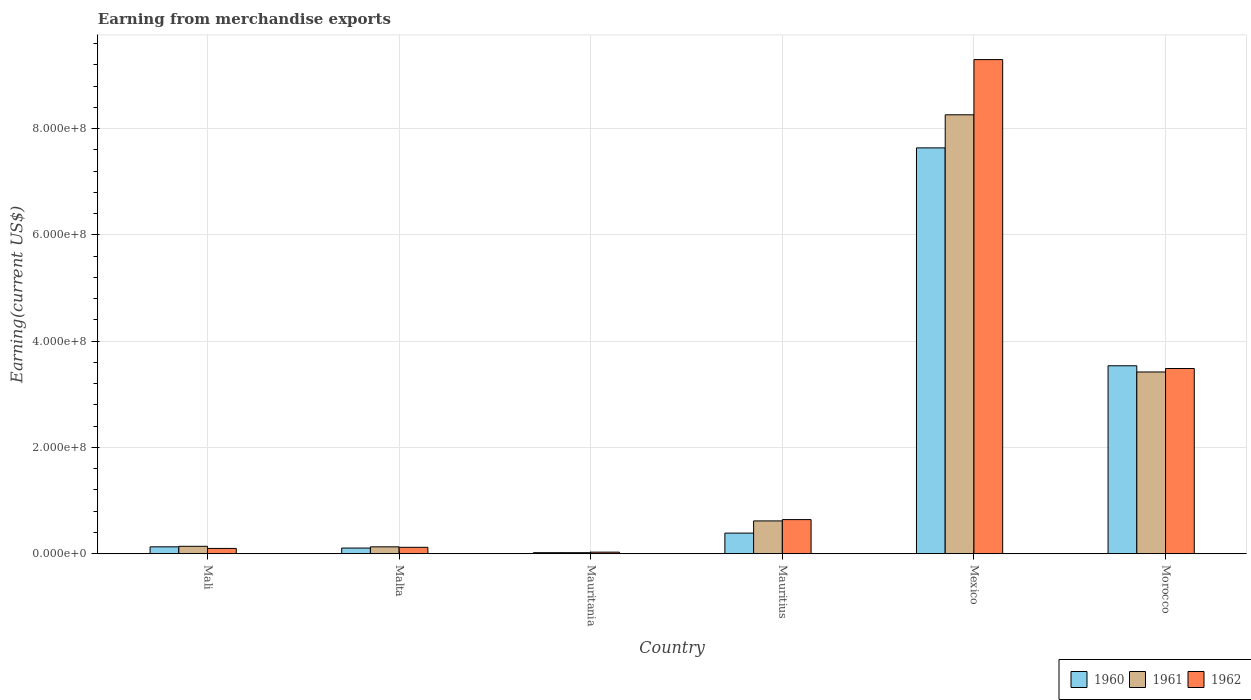How many groups of bars are there?
Make the answer very short. 6. How many bars are there on the 3rd tick from the left?
Your answer should be compact. 3. What is the amount earned from merchandise exports in 1960 in Mexico?
Provide a short and direct response. 7.64e+08. Across all countries, what is the maximum amount earned from merchandise exports in 1960?
Keep it short and to the point. 7.64e+08. Across all countries, what is the minimum amount earned from merchandise exports in 1961?
Ensure brevity in your answer.  2.00e+06. In which country was the amount earned from merchandise exports in 1961 minimum?
Provide a succinct answer. Mauritania. What is the total amount earned from merchandise exports in 1962 in the graph?
Provide a succinct answer. 1.37e+09. What is the difference between the amount earned from merchandise exports in 1960 in Mali and that in Mauritius?
Provide a succinct answer. -2.58e+07. What is the difference between the amount earned from merchandise exports in 1962 in Mauritania and the amount earned from merchandise exports in 1961 in Malta?
Provide a short and direct response. -1.00e+07. What is the average amount earned from merchandise exports in 1961 per country?
Make the answer very short. 2.10e+08. What is the difference between the amount earned from merchandise exports of/in 1960 and amount earned from merchandise exports of/in 1961 in Malta?
Keep it short and to the point. -2.30e+06. Is the amount earned from merchandise exports in 1961 in Mauritius less than that in Mexico?
Your response must be concise. Yes. What is the difference between the highest and the second highest amount earned from merchandise exports in 1960?
Your answer should be very brief. 4.10e+08. What is the difference between the highest and the lowest amount earned from merchandise exports in 1961?
Provide a short and direct response. 8.24e+08. In how many countries, is the amount earned from merchandise exports in 1960 greater than the average amount earned from merchandise exports in 1960 taken over all countries?
Keep it short and to the point. 2. Is the sum of the amount earned from merchandise exports in 1961 in Malta and Mauritania greater than the maximum amount earned from merchandise exports in 1960 across all countries?
Provide a succinct answer. No. Are all the bars in the graph horizontal?
Provide a short and direct response. No. What is the difference between two consecutive major ticks on the Y-axis?
Your answer should be very brief. 2.00e+08. Are the values on the major ticks of Y-axis written in scientific E-notation?
Your response must be concise. Yes. Does the graph contain any zero values?
Your answer should be compact. No. Does the graph contain grids?
Provide a short and direct response. Yes. Where does the legend appear in the graph?
Offer a terse response. Bottom right. How many legend labels are there?
Offer a very short reply. 3. What is the title of the graph?
Keep it short and to the point. Earning from merchandise exports. What is the label or title of the Y-axis?
Your answer should be very brief. Earning(current US$). What is the Earning(current US$) of 1960 in Mali?
Provide a succinct answer. 1.30e+07. What is the Earning(current US$) of 1961 in Mali?
Your response must be concise. 1.40e+07. What is the Earning(current US$) of 1960 in Malta?
Keep it short and to the point. 1.07e+07. What is the Earning(current US$) of 1961 in Malta?
Keep it short and to the point. 1.30e+07. What is the Earning(current US$) in 1962 in Malta?
Make the answer very short. 1.21e+07. What is the Earning(current US$) in 1960 in Mauritania?
Your answer should be very brief. 2.00e+06. What is the Earning(current US$) of 1962 in Mauritania?
Ensure brevity in your answer.  3.00e+06. What is the Earning(current US$) in 1960 in Mauritius?
Keep it short and to the point. 3.88e+07. What is the Earning(current US$) of 1961 in Mauritius?
Your answer should be compact. 6.18e+07. What is the Earning(current US$) of 1962 in Mauritius?
Provide a short and direct response. 6.42e+07. What is the Earning(current US$) in 1960 in Mexico?
Offer a very short reply. 7.64e+08. What is the Earning(current US$) in 1961 in Mexico?
Provide a short and direct response. 8.26e+08. What is the Earning(current US$) of 1962 in Mexico?
Keep it short and to the point. 9.30e+08. What is the Earning(current US$) of 1960 in Morocco?
Offer a terse response. 3.54e+08. What is the Earning(current US$) in 1961 in Morocco?
Provide a succinct answer. 3.42e+08. What is the Earning(current US$) in 1962 in Morocco?
Ensure brevity in your answer.  3.49e+08. Across all countries, what is the maximum Earning(current US$) of 1960?
Provide a succinct answer. 7.64e+08. Across all countries, what is the maximum Earning(current US$) in 1961?
Provide a succinct answer. 8.26e+08. Across all countries, what is the maximum Earning(current US$) of 1962?
Make the answer very short. 9.30e+08. Across all countries, what is the minimum Earning(current US$) in 1960?
Your response must be concise. 2.00e+06. Across all countries, what is the minimum Earning(current US$) of 1961?
Ensure brevity in your answer.  2.00e+06. What is the total Earning(current US$) of 1960 in the graph?
Offer a very short reply. 1.18e+09. What is the total Earning(current US$) of 1961 in the graph?
Ensure brevity in your answer.  1.26e+09. What is the total Earning(current US$) in 1962 in the graph?
Give a very brief answer. 1.37e+09. What is the difference between the Earning(current US$) in 1960 in Mali and that in Malta?
Ensure brevity in your answer.  2.29e+06. What is the difference between the Earning(current US$) in 1961 in Mali and that in Malta?
Provide a succinct answer. 9.86e+05. What is the difference between the Earning(current US$) in 1962 in Mali and that in Malta?
Your response must be concise. -2.08e+06. What is the difference between the Earning(current US$) of 1960 in Mali and that in Mauritania?
Your answer should be very brief. 1.10e+07. What is the difference between the Earning(current US$) in 1961 in Mali and that in Mauritania?
Your answer should be compact. 1.20e+07. What is the difference between the Earning(current US$) in 1960 in Mali and that in Mauritius?
Ensure brevity in your answer.  -2.58e+07. What is the difference between the Earning(current US$) of 1961 in Mali and that in Mauritius?
Provide a succinct answer. -4.78e+07. What is the difference between the Earning(current US$) of 1962 in Mali and that in Mauritius?
Make the answer very short. -5.42e+07. What is the difference between the Earning(current US$) in 1960 in Mali and that in Mexico?
Offer a terse response. -7.51e+08. What is the difference between the Earning(current US$) of 1961 in Mali and that in Mexico?
Offer a terse response. -8.12e+08. What is the difference between the Earning(current US$) of 1962 in Mali and that in Mexico?
Make the answer very short. -9.20e+08. What is the difference between the Earning(current US$) of 1960 in Mali and that in Morocco?
Provide a short and direct response. -3.41e+08. What is the difference between the Earning(current US$) of 1961 in Mali and that in Morocco?
Your response must be concise. -3.28e+08. What is the difference between the Earning(current US$) in 1962 in Mali and that in Morocco?
Provide a succinct answer. -3.39e+08. What is the difference between the Earning(current US$) in 1960 in Malta and that in Mauritania?
Ensure brevity in your answer.  8.71e+06. What is the difference between the Earning(current US$) in 1961 in Malta and that in Mauritania?
Provide a short and direct response. 1.10e+07. What is the difference between the Earning(current US$) of 1962 in Malta and that in Mauritania?
Give a very brief answer. 9.08e+06. What is the difference between the Earning(current US$) in 1960 in Malta and that in Mauritius?
Offer a terse response. -2.81e+07. What is the difference between the Earning(current US$) in 1961 in Malta and that in Mauritius?
Keep it short and to the point. -4.88e+07. What is the difference between the Earning(current US$) of 1962 in Malta and that in Mauritius?
Provide a short and direct response. -5.22e+07. What is the difference between the Earning(current US$) of 1960 in Malta and that in Mexico?
Keep it short and to the point. -7.53e+08. What is the difference between the Earning(current US$) in 1961 in Malta and that in Mexico?
Your answer should be compact. -8.13e+08. What is the difference between the Earning(current US$) of 1962 in Malta and that in Mexico?
Give a very brief answer. -9.18e+08. What is the difference between the Earning(current US$) of 1960 in Malta and that in Morocco?
Offer a very short reply. -3.43e+08. What is the difference between the Earning(current US$) of 1961 in Malta and that in Morocco?
Keep it short and to the point. -3.29e+08. What is the difference between the Earning(current US$) of 1962 in Malta and that in Morocco?
Your response must be concise. -3.37e+08. What is the difference between the Earning(current US$) in 1960 in Mauritania and that in Mauritius?
Provide a short and direct response. -3.68e+07. What is the difference between the Earning(current US$) of 1961 in Mauritania and that in Mauritius?
Offer a very short reply. -5.98e+07. What is the difference between the Earning(current US$) in 1962 in Mauritania and that in Mauritius?
Offer a very short reply. -6.12e+07. What is the difference between the Earning(current US$) of 1960 in Mauritania and that in Mexico?
Your response must be concise. -7.62e+08. What is the difference between the Earning(current US$) of 1961 in Mauritania and that in Mexico?
Your answer should be compact. -8.24e+08. What is the difference between the Earning(current US$) of 1962 in Mauritania and that in Mexico?
Keep it short and to the point. -9.27e+08. What is the difference between the Earning(current US$) of 1960 in Mauritania and that in Morocco?
Provide a short and direct response. -3.52e+08. What is the difference between the Earning(current US$) of 1961 in Mauritania and that in Morocco?
Give a very brief answer. -3.40e+08. What is the difference between the Earning(current US$) of 1962 in Mauritania and that in Morocco?
Your answer should be very brief. -3.46e+08. What is the difference between the Earning(current US$) of 1960 in Mauritius and that in Mexico?
Your answer should be compact. -7.25e+08. What is the difference between the Earning(current US$) in 1961 in Mauritius and that in Mexico?
Provide a short and direct response. -7.64e+08. What is the difference between the Earning(current US$) of 1962 in Mauritius and that in Mexico?
Make the answer very short. -8.66e+08. What is the difference between the Earning(current US$) of 1960 in Mauritius and that in Morocco?
Make the answer very short. -3.15e+08. What is the difference between the Earning(current US$) of 1961 in Mauritius and that in Morocco?
Provide a short and direct response. -2.80e+08. What is the difference between the Earning(current US$) in 1962 in Mauritius and that in Morocco?
Give a very brief answer. -2.84e+08. What is the difference between the Earning(current US$) in 1960 in Mexico and that in Morocco?
Give a very brief answer. 4.10e+08. What is the difference between the Earning(current US$) of 1961 in Mexico and that in Morocco?
Give a very brief answer. 4.84e+08. What is the difference between the Earning(current US$) in 1962 in Mexico and that in Morocco?
Give a very brief answer. 5.81e+08. What is the difference between the Earning(current US$) in 1960 in Mali and the Earning(current US$) in 1961 in Malta?
Offer a terse response. -1.44e+04. What is the difference between the Earning(current US$) of 1960 in Mali and the Earning(current US$) of 1962 in Malta?
Provide a short and direct response. 9.18e+05. What is the difference between the Earning(current US$) of 1961 in Mali and the Earning(current US$) of 1962 in Malta?
Your answer should be compact. 1.92e+06. What is the difference between the Earning(current US$) in 1960 in Mali and the Earning(current US$) in 1961 in Mauritania?
Offer a very short reply. 1.10e+07. What is the difference between the Earning(current US$) in 1960 in Mali and the Earning(current US$) in 1962 in Mauritania?
Your answer should be compact. 1.00e+07. What is the difference between the Earning(current US$) in 1961 in Mali and the Earning(current US$) in 1962 in Mauritania?
Offer a very short reply. 1.10e+07. What is the difference between the Earning(current US$) of 1960 in Mali and the Earning(current US$) of 1961 in Mauritius?
Offer a terse response. -4.88e+07. What is the difference between the Earning(current US$) in 1960 in Mali and the Earning(current US$) in 1962 in Mauritius?
Ensure brevity in your answer.  -5.12e+07. What is the difference between the Earning(current US$) in 1961 in Mali and the Earning(current US$) in 1962 in Mauritius?
Your answer should be compact. -5.02e+07. What is the difference between the Earning(current US$) in 1960 in Mali and the Earning(current US$) in 1961 in Mexico?
Ensure brevity in your answer.  -8.13e+08. What is the difference between the Earning(current US$) in 1960 in Mali and the Earning(current US$) in 1962 in Mexico?
Your response must be concise. -9.17e+08. What is the difference between the Earning(current US$) of 1961 in Mali and the Earning(current US$) of 1962 in Mexico?
Your answer should be compact. -9.16e+08. What is the difference between the Earning(current US$) of 1960 in Mali and the Earning(current US$) of 1961 in Morocco?
Offer a terse response. -3.29e+08. What is the difference between the Earning(current US$) in 1960 in Mali and the Earning(current US$) in 1962 in Morocco?
Ensure brevity in your answer.  -3.36e+08. What is the difference between the Earning(current US$) of 1961 in Mali and the Earning(current US$) of 1962 in Morocco?
Make the answer very short. -3.35e+08. What is the difference between the Earning(current US$) of 1960 in Malta and the Earning(current US$) of 1961 in Mauritania?
Offer a terse response. 8.71e+06. What is the difference between the Earning(current US$) in 1960 in Malta and the Earning(current US$) in 1962 in Mauritania?
Give a very brief answer. 7.71e+06. What is the difference between the Earning(current US$) of 1961 in Malta and the Earning(current US$) of 1962 in Mauritania?
Offer a very short reply. 1.00e+07. What is the difference between the Earning(current US$) in 1960 in Malta and the Earning(current US$) in 1961 in Mauritius?
Offer a very short reply. -5.11e+07. What is the difference between the Earning(current US$) of 1960 in Malta and the Earning(current US$) of 1962 in Mauritius?
Provide a short and direct response. -5.35e+07. What is the difference between the Earning(current US$) of 1961 in Malta and the Earning(current US$) of 1962 in Mauritius?
Provide a short and direct response. -5.12e+07. What is the difference between the Earning(current US$) in 1960 in Malta and the Earning(current US$) in 1961 in Mexico?
Your answer should be very brief. -8.15e+08. What is the difference between the Earning(current US$) of 1960 in Malta and the Earning(current US$) of 1962 in Mexico?
Keep it short and to the point. -9.19e+08. What is the difference between the Earning(current US$) of 1961 in Malta and the Earning(current US$) of 1962 in Mexico?
Provide a short and direct response. -9.17e+08. What is the difference between the Earning(current US$) of 1960 in Malta and the Earning(current US$) of 1961 in Morocco?
Ensure brevity in your answer.  -3.31e+08. What is the difference between the Earning(current US$) in 1960 in Malta and the Earning(current US$) in 1962 in Morocco?
Ensure brevity in your answer.  -3.38e+08. What is the difference between the Earning(current US$) of 1961 in Malta and the Earning(current US$) of 1962 in Morocco?
Provide a short and direct response. -3.36e+08. What is the difference between the Earning(current US$) in 1960 in Mauritania and the Earning(current US$) in 1961 in Mauritius?
Offer a terse response. -5.98e+07. What is the difference between the Earning(current US$) of 1960 in Mauritania and the Earning(current US$) of 1962 in Mauritius?
Make the answer very short. -6.22e+07. What is the difference between the Earning(current US$) of 1961 in Mauritania and the Earning(current US$) of 1962 in Mauritius?
Offer a very short reply. -6.22e+07. What is the difference between the Earning(current US$) of 1960 in Mauritania and the Earning(current US$) of 1961 in Mexico?
Ensure brevity in your answer.  -8.24e+08. What is the difference between the Earning(current US$) in 1960 in Mauritania and the Earning(current US$) in 1962 in Mexico?
Your answer should be compact. -9.28e+08. What is the difference between the Earning(current US$) of 1961 in Mauritania and the Earning(current US$) of 1962 in Mexico?
Offer a very short reply. -9.28e+08. What is the difference between the Earning(current US$) of 1960 in Mauritania and the Earning(current US$) of 1961 in Morocco?
Offer a terse response. -3.40e+08. What is the difference between the Earning(current US$) in 1960 in Mauritania and the Earning(current US$) in 1962 in Morocco?
Give a very brief answer. -3.47e+08. What is the difference between the Earning(current US$) of 1961 in Mauritania and the Earning(current US$) of 1962 in Morocco?
Make the answer very short. -3.47e+08. What is the difference between the Earning(current US$) in 1960 in Mauritius and the Earning(current US$) in 1961 in Mexico?
Keep it short and to the point. -7.87e+08. What is the difference between the Earning(current US$) in 1960 in Mauritius and the Earning(current US$) in 1962 in Mexico?
Offer a very short reply. -8.91e+08. What is the difference between the Earning(current US$) in 1961 in Mauritius and the Earning(current US$) in 1962 in Mexico?
Ensure brevity in your answer.  -8.68e+08. What is the difference between the Earning(current US$) of 1960 in Mauritius and the Earning(current US$) of 1961 in Morocco?
Provide a succinct answer. -3.03e+08. What is the difference between the Earning(current US$) of 1960 in Mauritius and the Earning(current US$) of 1962 in Morocco?
Your answer should be compact. -3.10e+08. What is the difference between the Earning(current US$) in 1961 in Mauritius and the Earning(current US$) in 1962 in Morocco?
Your answer should be very brief. -2.87e+08. What is the difference between the Earning(current US$) in 1960 in Mexico and the Earning(current US$) in 1961 in Morocco?
Provide a succinct answer. 4.22e+08. What is the difference between the Earning(current US$) in 1960 in Mexico and the Earning(current US$) in 1962 in Morocco?
Offer a very short reply. 4.15e+08. What is the difference between the Earning(current US$) in 1961 in Mexico and the Earning(current US$) in 1962 in Morocco?
Provide a short and direct response. 4.77e+08. What is the average Earning(current US$) of 1960 per country?
Ensure brevity in your answer.  1.97e+08. What is the average Earning(current US$) in 1961 per country?
Make the answer very short. 2.10e+08. What is the average Earning(current US$) of 1962 per country?
Keep it short and to the point. 2.28e+08. What is the difference between the Earning(current US$) in 1960 and Earning(current US$) in 1962 in Mali?
Make the answer very short. 3.00e+06. What is the difference between the Earning(current US$) in 1961 and Earning(current US$) in 1962 in Mali?
Make the answer very short. 4.00e+06. What is the difference between the Earning(current US$) in 1960 and Earning(current US$) in 1961 in Malta?
Offer a terse response. -2.30e+06. What is the difference between the Earning(current US$) of 1960 and Earning(current US$) of 1962 in Malta?
Provide a succinct answer. -1.37e+06. What is the difference between the Earning(current US$) of 1961 and Earning(current US$) of 1962 in Malta?
Give a very brief answer. 9.32e+05. What is the difference between the Earning(current US$) in 1960 and Earning(current US$) in 1962 in Mauritania?
Your response must be concise. -1.00e+06. What is the difference between the Earning(current US$) of 1961 and Earning(current US$) of 1962 in Mauritania?
Make the answer very short. -1.00e+06. What is the difference between the Earning(current US$) of 1960 and Earning(current US$) of 1961 in Mauritius?
Your answer should be very brief. -2.29e+07. What is the difference between the Earning(current US$) in 1960 and Earning(current US$) in 1962 in Mauritius?
Your response must be concise. -2.54e+07. What is the difference between the Earning(current US$) of 1961 and Earning(current US$) of 1962 in Mauritius?
Provide a succinct answer. -2.46e+06. What is the difference between the Earning(current US$) of 1960 and Earning(current US$) of 1961 in Mexico?
Make the answer very short. -6.22e+07. What is the difference between the Earning(current US$) of 1960 and Earning(current US$) of 1962 in Mexico?
Provide a succinct answer. -1.66e+08. What is the difference between the Earning(current US$) in 1961 and Earning(current US$) in 1962 in Mexico?
Provide a short and direct response. -1.04e+08. What is the difference between the Earning(current US$) of 1960 and Earning(current US$) of 1961 in Morocco?
Your response must be concise. 1.17e+07. What is the difference between the Earning(current US$) of 1960 and Earning(current US$) of 1962 in Morocco?
Make the answer very short. 5.14e+06. What is the difference between the Earning(current US$) of 1961 and Earning(current US$) of 1962 in Morocco?
Give a very brief answer. -6.52e+06. What is the ratio of the Earning(current US$) in 1960 in Mali to that in Malta?
Offer a very short reply. 1.21. What is the ratio of the Earning(current US$) of 1961 in Mali to that in Malta?
Offer a very short reply. 1.08. What is the ratio of the Earning(current US$) of 1962 in Mali to that in Malta?
Provide a short and direct response. 0.83. What is the ratio of the Earning(current US$) in 1960 in Mali to that in Mauritius?
Your answer should be very brief. 0.33. What is the ratio of the Earning(current US$) of 1961 in Mali to that in Mauritius?
Make the answer very short. 0.23. What is the ratio of the Earning(current US$) in 1962 in Mali to that in Mauritius?
Your answer should be compact. 0.16. What is the ratio of the Earning(current US$) in 1960 in Mali to that in Mexico?
Keep it short and to the point. 0.02. What is the ratio of the Earning(current US$) of 1961 in Mali to that in Mexico?
Give a very brief answer. 0.02. What is the ratio of the Earning(current US$) of 1962 in Mali to that in Mexico?
Offer a terse response. 0.01. What is the ratio of the Earning(current US$) of 1960 in Mali to that in Morocco?
Make the answer very short. 0.04. What is the ratio of the Earning(current US$) of 1961 in Mali to that in Morocco?
Your answer should be very brief. 0.04. What is the ratio of the Earning(current US$) of 1962 in Mali to that in Morocco?
Your answer should be compact. 0.03. What is the ratio of the Earning(current US$) of 1960 in Malta to that in Mauritania?
Make the answer very short. 5.36. What is the ratio of the Earning(current US$) of 1961 in Malta to that in Mauritania?
Provide a short and direct response. 6.51. What is the ratio of the Earning(current US$) of 1962 in Malta to that in Mauritania?
Keep it short and to the point. 4.03. What is the ratio of the Earning(current US$) in 1960 in Malta to that in Mauritius?
Make the answer very short. 0.28. What is the ratio of the Earning(current US$) in 1961 in Malta to that in Mauritius?
Your response must be concise. 0.21. What is the ratio of the Earning(current US$) of 1962 in Malta to that in Mauritius?
Offer a very short reply. 0.19. What is the ratio of the Earning(current US$) of 1960 in Malta to that in Mexico?
Keep it short and to the point. 0.01. What is the ratio of the Earning(current US$) in 1961 in Malta to that in Mexico?
Your answer should be compact. 0.02. What is the ratio of the Earning(current US$) in 1962 in Malta to that in Mexico?
Your response must be concise. 0.01. What is the ratio of the Earning(current US$) in 1960 in Malta to that in Morocco?
Make the answer very short. 0.03. What is the ratio of the Earning(current US$) in 1961 in Malta to that in Morocco?
Your response must be concise. 0.04. What is the ratio of the Earning(current US$) of 1962 in Malta to that in Morocco?
Your answer should be compact. 0.03. What is the ratio of the Earning(current US$) of 1960 in Mauritania to that in Mauritius?
Offer a terse response. 0.05. What is the ratio of the Earning(current US$) in 1961 in Mauritania to that in Mauritius?
Ensure brevity in your answer.  0.03. What is the ratio of the Earning(current US$) in 1962 in Mauritania to that in Mauritius?
Offer a terse response. 0.05. What is the ratio of the Earning(current US$) of 1960 in Mauritania to that in Mexico?
Keep it short and to the point. 0. What is the ratio of the Earning(current US$) in 1961 in Mauritania to that in Mexico?
Keep it short and to the point. 0. What is the ratio of the Earning(current US$) of 1962 in Mauritania to that in Mexico?
Offer a very short reply. 0. What is the ratio of the Earning(current US$) of 1960 in Mauritania to that in Morocco?
Provide a succinct answer. 0.01. What is the ratio of the Earning(current US$) in 1961 in Mauritania to that in Morocco?
Provide a short and direct response. 0.01. What is the ratio of the Earning(current US$) of 1962 in Mauritania to that in Morocco?
Offer a terse response. 0.01. What is the ratio of the Earning(current US$) in 1960 in Mauritius to that in Mexico?
Offer a very short reply. 0.05. What is the ratio of the Earning(current US$) in 1961 in Mauritius to that in Mexico?
Give a very brief answer. 0.07. What is the ratio of the Earning(current US$) in 1962 in Mauritius to that in Mexico?
Give a very brief answer. 0.07. What is the ratio of the Earning(current US$) in 1960 in Mauritius to that in Morocco?
Give a very brief answer. 0.11. What is the ratio of the Earning(current US$) in 1961 in Mauritius to that in Morocco?
Ensure brevity in your answer.  0.18. What is the ratio of the Earning(current US$) of 1962 in Mauritius to that in Morocco?
Give a very brief answer. 0.18. What is the ratio of the Earning(current US$) of 1960 in Mexico to that in Morocco?
Provide a succinct answer. 2.16. What is the ratio of the Earning(current US$) of 1961 in Mexico to that in Morocco?
Provide a succinct answer. 2.41. What is the ratio of the Earning(current US$) of 1962 in Mexico to that in Morocco?
Your answer should be very brief. 2.67. What is the difference between the highest and the second highest Earning(current US$) in 1960?
Keep it short and to the point. 4.10e+08. What is the difference between the highest and the second highest Earning(current US$) in 1961?
Provide a succinct answer. 4.84e+08. What is the difference between the highest and the second highest Earning(current US$) in 1962?
Make the answer very short. 5.81e+08. What is the difference between the highest and the lowest Earning(current US$) of 1960?
Your answer should be very brief. 7.62e+08. What is the difference between the highest and the lowest Earning(current US$) of 1961?
Your response must be concise. 8.24e+08. What is the difference between the highest and the lowest Earning(current US$) of 1962?
Offer a very short reply. 9.27e+08. 